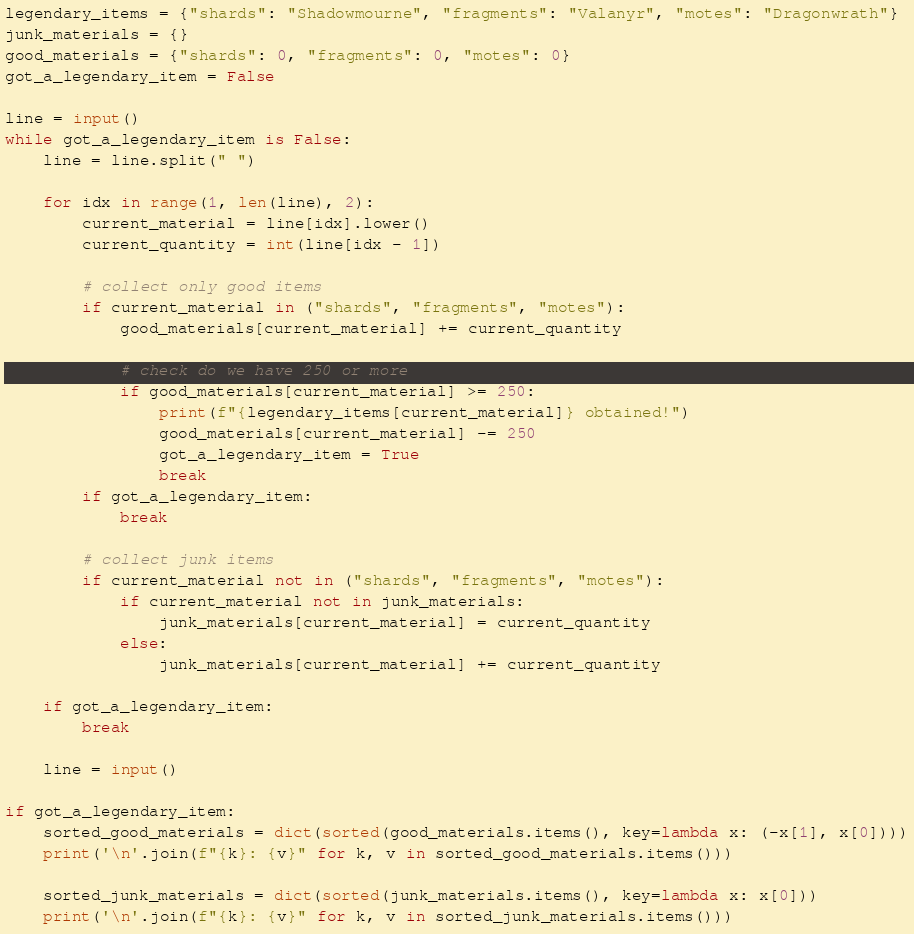<code> <loc_0><loc_0><loc_500><loc_500><_Python_>legendary_items = {"shards": "Shadowmourne", "fragments": "Valanyr", "motes": "Dragonwrath"}
junk_materials = {}
good_materials = {"shards": 0, "fragments": 0, "motes": 0}
got_a_legendary_item = False

line = input()
while got_a_legendary_item is False:
    line = line.split(" ")

    for idx in range(1, len(line), 2):
        current_material = line[idx].lower()
        current_quantity = int(line[idx - 1])

        # collect only good items
        if current_material in ("shards", "fragments", "motes"):
            good_materials[current_material] += current_quantity

            # check do we have 250 or more
            if good_materials[current_material] >= 250:
                print(f"{legendary_items[current_material]} obtained!")
                good_materials[current_material] -= 250
                got_a_legendary_item = True
                break
        if got_a_legendary_item:
            break

        # collect junk items
        if current_material not in ("shards", "fragments", "motes"):
            if current_material not in junk_materials:
                junk_materials[current_material] = current_quantity
            else:
                junk_materials[current_material] += current_quantity

    if got_a_legendary_item:
        break

    line = input()

if got_a_legendary_item:
    sorted_good_materials = dict(sorted(good_materials.items(), key=lambda x: (-x[1], x[0])))
    print('\n'.join(f"{k}: {v}" for k, v in sorted_good_materials.items()))

    sorted_junk_materials = dict(sorted(junk_materials.items(), key=lambda x: x[0]))
    print('\n'.join(f"{k}: {v}" for k, v in sorted_junk_materials.items()))</code> 